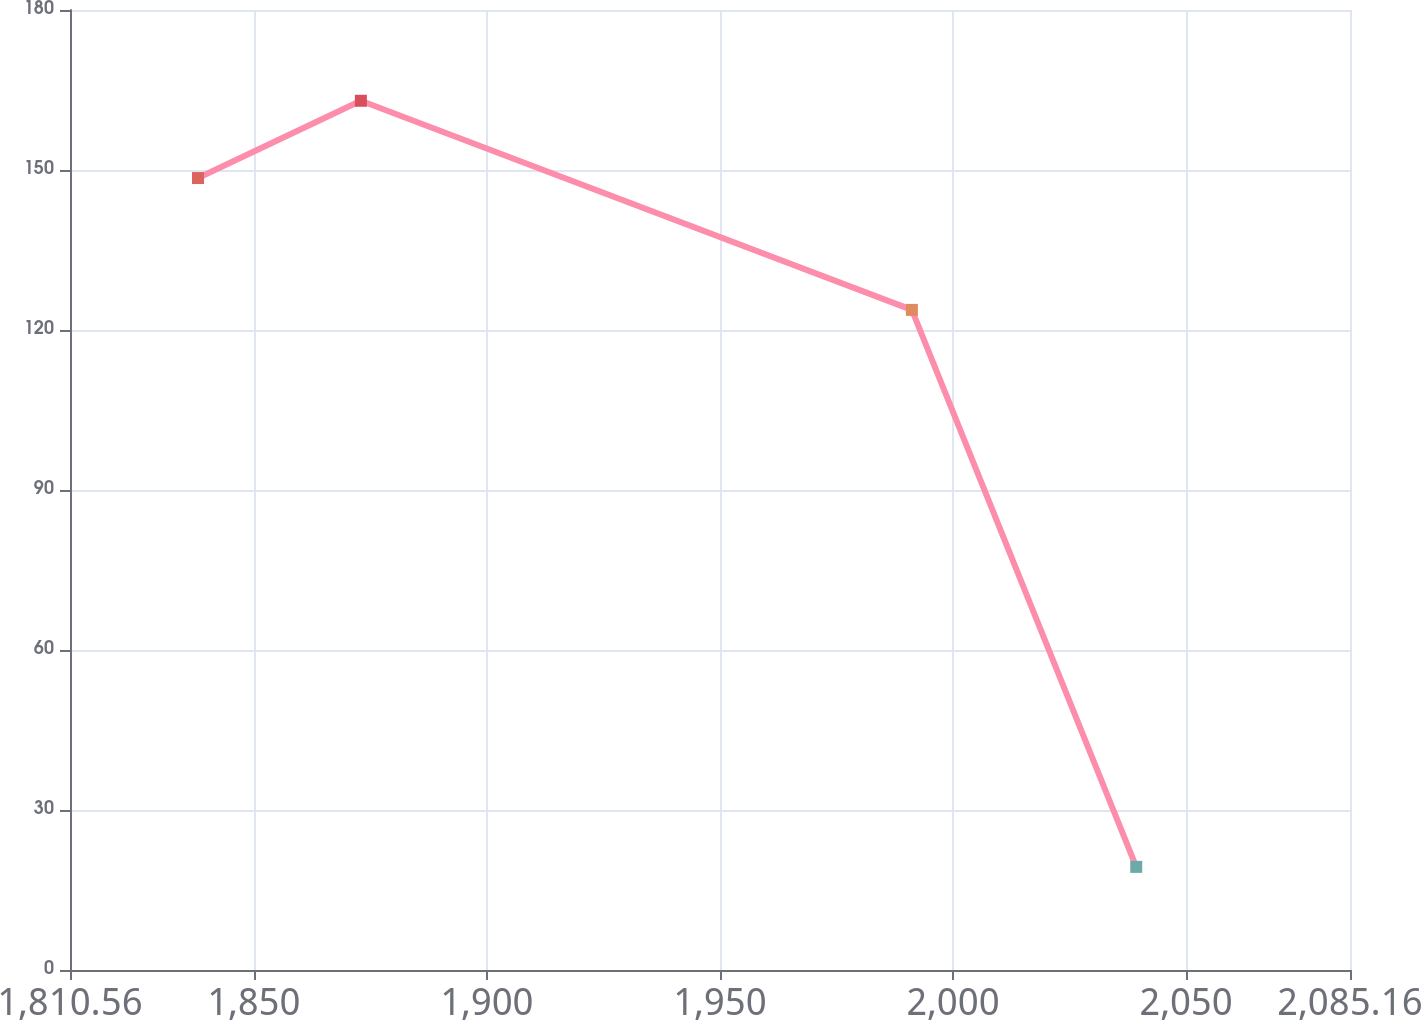<chart> <loc_0><loc_0><loc_500><loc_500><line_chart><ecel><fcel>($ in millions)<nl><fcel>1838.02<fcel>148.49<nl><fcel>1872.96<fcel>162.98<nl><fcel>1991.17<fcel>123.77<nl><fcel>2039.3<fcel>19.34<nl><fcel>2112.62<fcel>4.85<nl></chart> 